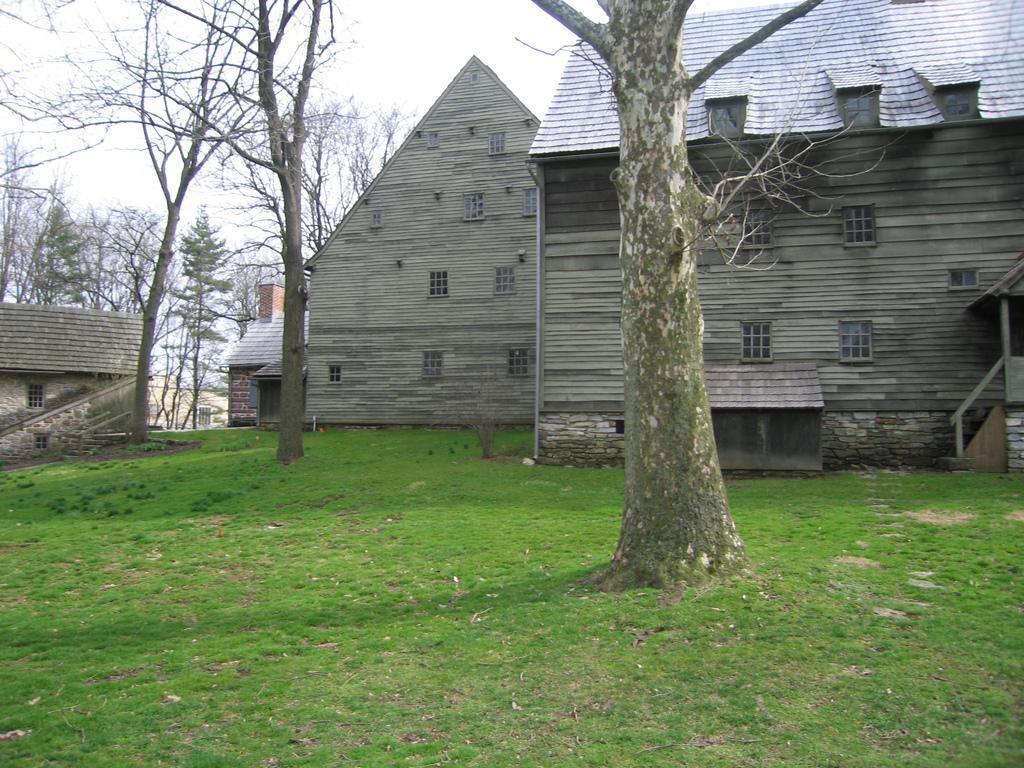In one or two sentences, can you explain what this image depicts? In this image we can see some houses, one staircase, some trees, some dried trees, few objects on the ground, some grass on the ground and at the top there is the sky. 